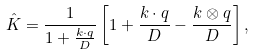Convert formula to latex. <formula><loc_0><loc_0><loc_500><loc_500>\hat { K } = \frac { 1 } { 1 + \frac { { k } \cdot { q } } { D } } \left [ 1 + \frac { { k } \cdot { q } } { D } - \frac { { k } \otimes { q } } { D } \right ] ,</formula> 